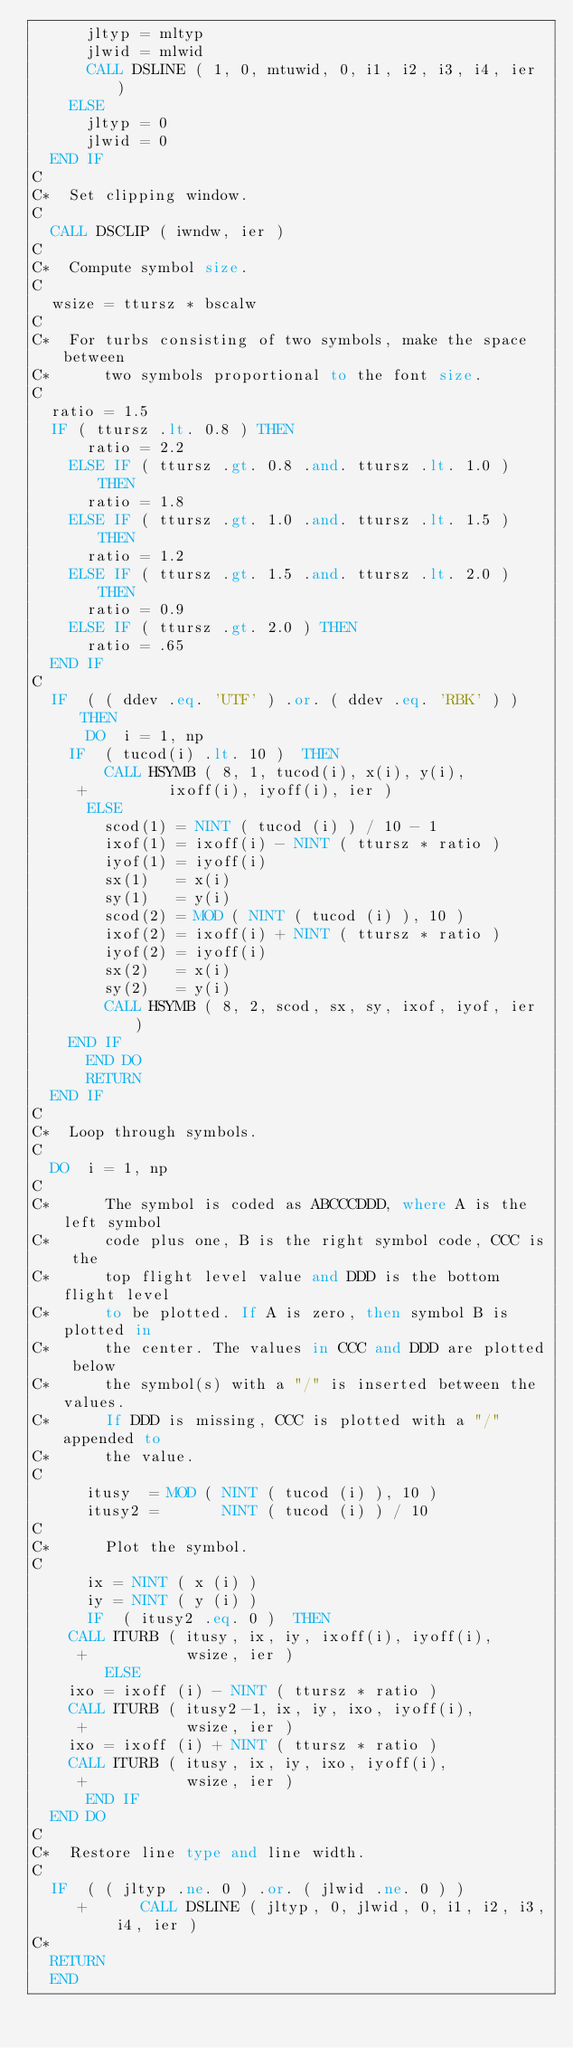Convert code to text. <code><loc_0><loc_0><loc_500><loc_500><_FORTRAN_>	    jltyp = mltyp
	    jlwid = mlwid
	    CALL DSLINE ( 1, 0, mtuwid, 0, i1, i2, i3, i4, ier )
	  ELSE
	    jltyp = 0
	    jlwid = 0
	END IF
C
C*	Set clipping window.
C
	CALL DSCLIP ( iwndw, ier )
C
C*	Compute symbol size.
C
	wsize = ttursz * bscalw
C
C*	For turbs consisting of two symbols, make the space between
C*      two symbols proportional to the font size.
C
	ratio = 1.5
	IF ( ttursz .lt. 0.8 ) THEN
	    ratio = 2.2
	  ELSE IF ( ttursz .gt. 0.8 .and. ttursz .lt. 1.0 ) THEN
	    ratio = 1.8
	  ELSE IF ( ttursz .gt. 1.0 .and. ttursz .lt. 1.5 ) THEN
	    ratio = 1.2
	  ELSE IF ( ttursz .gt. 1.5 .and. ttursz .lt. 2.0 ) THEN
	    ratio = 0.9		
	  ELSE IF ( ttursz .gt. 2.0 ) THEN
	    ratio = .65		
	END IF
C
	IF  ( ( ddev .eq. 'UTF' ) .or. ( ddev .eq. 'RBK' ) ) THEN
	    DO  i = 1, np
		IF  ( tucod(i) .lt. 10 )  THEN
		    CALL HSYMB ( 8, 1, tucod(i), x(i), y(i),
     +				 ixoff(i), iyoff(i), ier )
		  ELSE
		    scod(1) = NINT ( tucod (i) ) / 10 - 1
		    ixof(1) = ixoff(i) - NINT ( ttursz * ratio )
		    iyof(1) = iyoff(i)
		    sx(1)   = x(i)
		    sy(1)   = y(i)
		    scod(2) = MOD ( NINT ( tucod (i) ), 10 )
		    ixof(2) = ixoff(i) + NINT ( ttursz * ratio )
		    iyof(2) = iyoff(i)
		    sx(2)   = x(i)
		    sy(2)   = y(i)
		    CALL HSYMB ( 8, 2, scod, sx, sy, ixof, iyof, ier )
		END IF
	    END DO
	    RETURN
	END IF
C
C*	Loop through symbols.
C
	DO  i = 1, np
C
C*	    The symbol is coded as ABCCCDDD, where A is the left symbol
C*	    code plus one, B is the right symbol code, CCC is the
C*	    top flight level value and DDD is the bottom flight level
C*	    to be plotted. If A is zero, then symbol B is plotted in
C*	    the center. The values in CCC and DDD are plotted below
C*	    the symbol(s) with a "/" is inserted between the values.
C*	    If DDD is missing, CCC is plotted with a "/" appended to 
C*	    the value.
C
	    itusy  = MOD ( NINT ( tucod (i) ), 10 )
	    itusy2 =       NINT ( tucod (i) ) / 10
C
C*	    Plot the symbol.
C
	    ix = NINT ( x (i) )
	    iy = NINT ( y (i) )
	    IF  ( itusy2 .eq. 0 )  THEN
		CALL ITURB ( itusy, ix, iy, ixoff(i), iyoff(i),
     +			     wsize, ier )
	      ELSE
		ixo = ixoff (i) - NINT ( ttursz * ratio )
		CALL ITURB ( itusy2-1, ix, iy, ixo, iyoff(i),
     +			     wsize, ier )
		ixo = ixoff (i) + NINT ( ttursz * ratio )
		CALL ITURB ( itusy, ix, iy, ixo, iyoff(i),
     +			     wsize, ier )
	    END IF
	END DO
C
C*	Restore line type and line width.
C
	IF  ( ( jltyp .ne. 0 ) .or. ( jlwid .ne. 0 ) )
     +	    CALL DSLINE ( jltyp, 0, jlwid, 0, i1, i2, i3, i4, ier )
C*
	RETURN
	END
</code> 